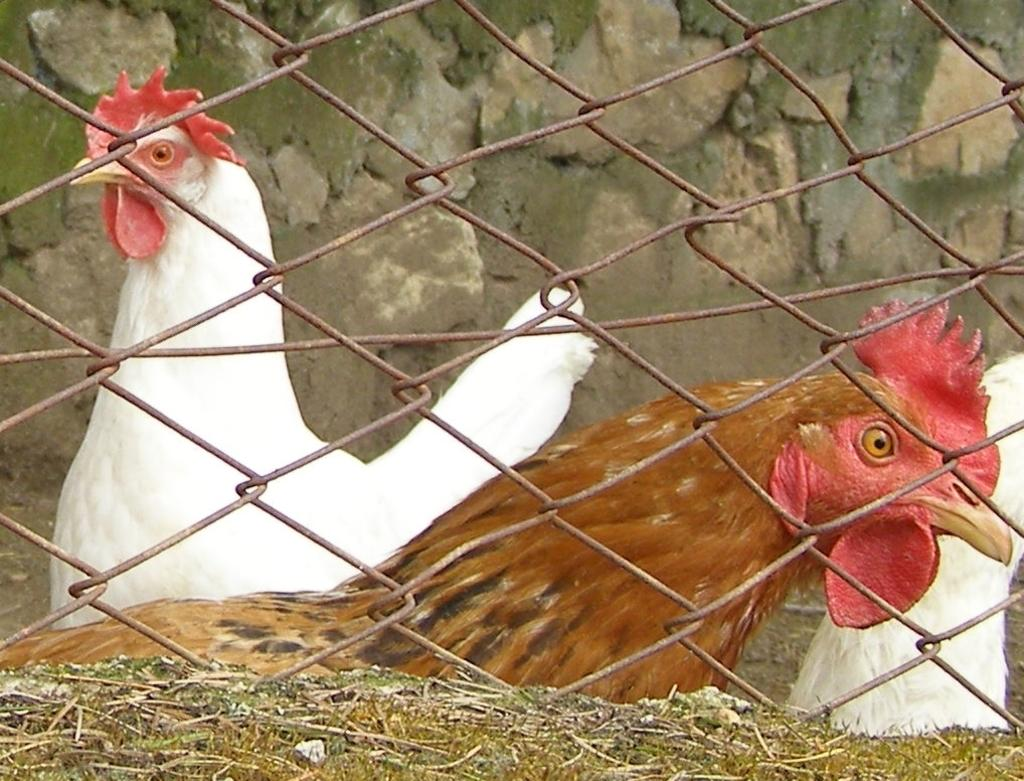How many chickens are present in the image? There are 3 chickens in the image. What colors are the chickens? Two of the chickens are white, and one is brown. What can be seen in the image to contain or separate the chickens? There is fencing in the image. What is visible in the background of the image? There is a wall in the background of the image. What type of lamp is hanging from the wall in the image? There is no lamp present in the image; it features chickens and fencing. What kind of loaf is being prepared by the chickens in the image? There is no loaf or baking activity depicted in the image; it shows chickens and fencing. 